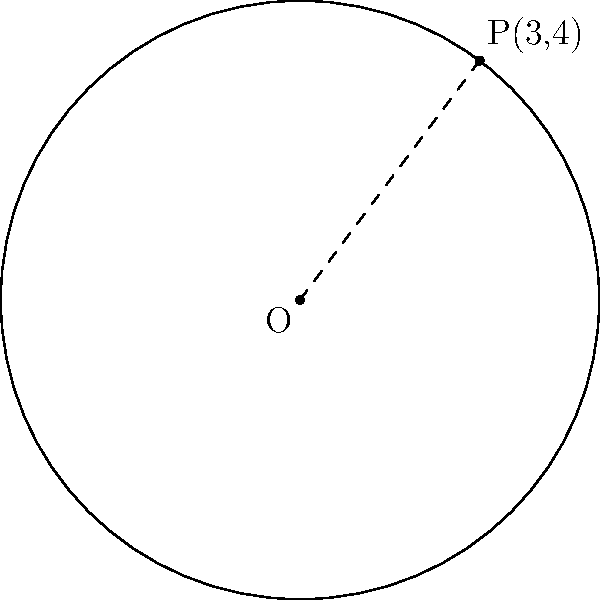In a circular dance formation, the center is at the origin (0,0), and one dancer is positioned at the point P(3,4). Find the equation of this circular formation. Let's approach this step-by-step:

1) The general equation of a circle is $$(x-h)^2 + (y-k)^2 = r^2$$
   where (h,k) is the center and r is the radius.

2) We're given that the center is at the origin (0,0), so h = 0 and k = 0.

3) Our equation simplifies to: $$x^2 + y^2 = r^2$$

4) To find r, we can use the distance formula between the center (0,0) and the point P(3,4):

   $$r^2 = (x-0)^2 + (y-0)^2 = 3^2 + 4^2 = 9 + 16 = 25$$

5) Therefore, $r = \sqrt{25} = 5$

6) Substituting this back into our equation:

   $$x^2 + y^2 = 5^2 = 25$$

This is the equation of our circular dance formation.
Answer: $x^2 + y^2 = 25$ 